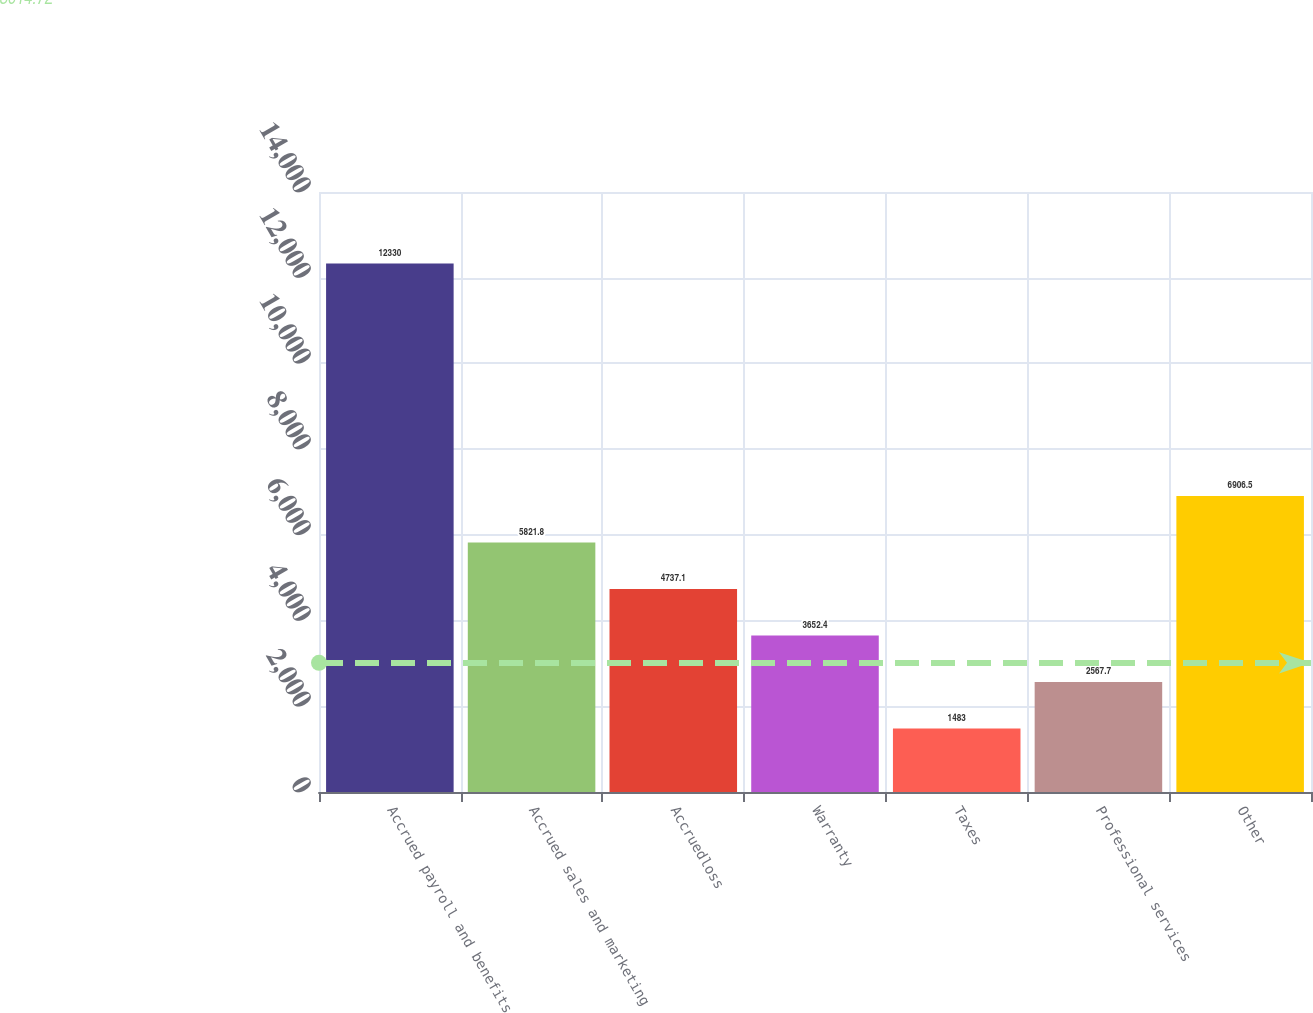Convert chart. <chart><loc_0><loc_0><loc_500><loc_500><bar_chart><fcel>Accrued payroll and benefits<fcel>Accrued sales and marketing<fcel>Accruedloss<fcel>Warranty<fcel>Taxes<fcel>Professional services<fcel>Other<nl><fcel>12330<fcel>5821.8<fcel>4737.1<fcel>3652.4<fcel>1483<fcel>2567.7<fcel>6906.5<nl></chart> 